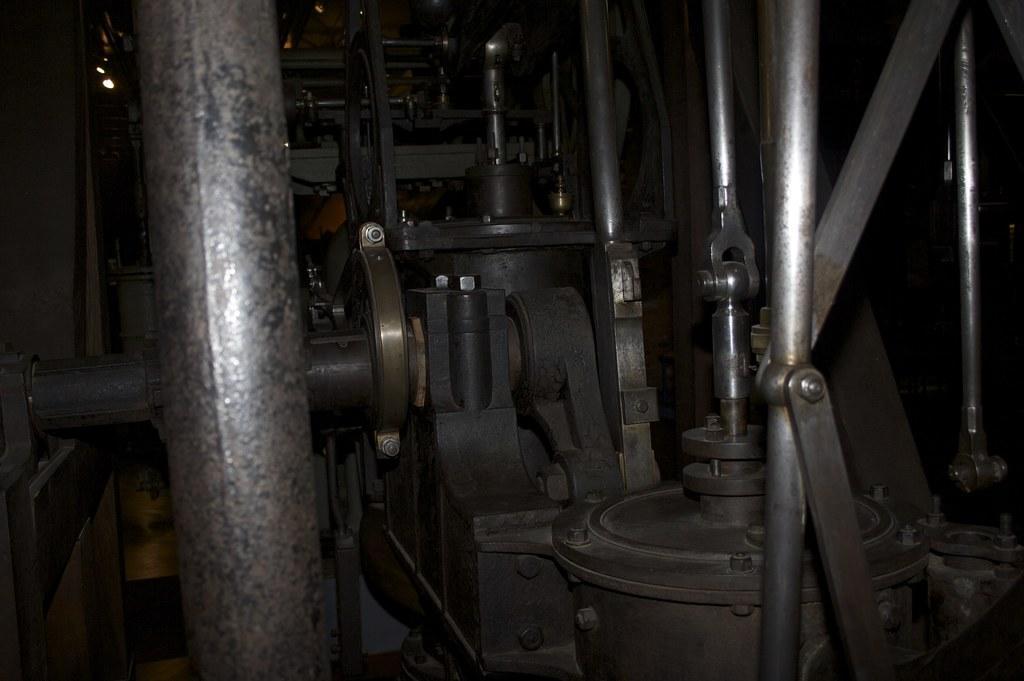In one or two sentences, can you explain what this image depicts? In this picture we can see rods, lights and some objects and in the background it is dark. 